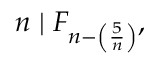<formula> <loc_0><loc_0><loc_500><loc_500>n | F _ { n - \left ( { \frac { 5 } { n } } \right ) } ,</formula> 